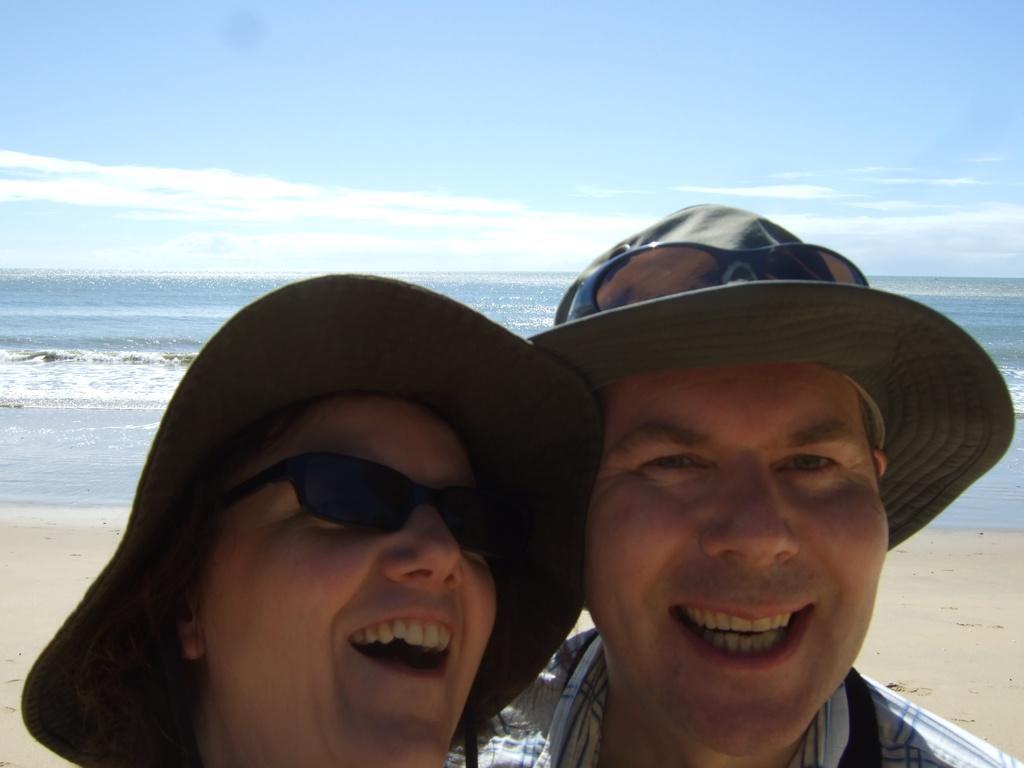Please provide a concise description of this image. In this image we can see there is a man and woman with hats standing together in beach are smiling. 